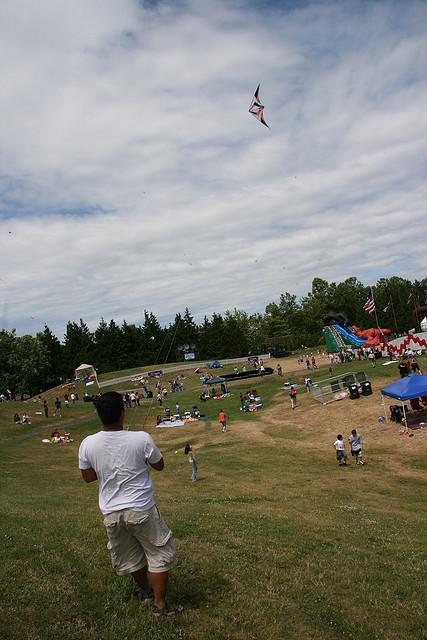What country's flag is flying in the distance?
Concise answer only. Usa. What are they flying?
Give a very brief answer. Kite. What type of terrain is in the background?
Answer briefly. Hills. Where is the kite?
Give a very brief answer. Sky. 